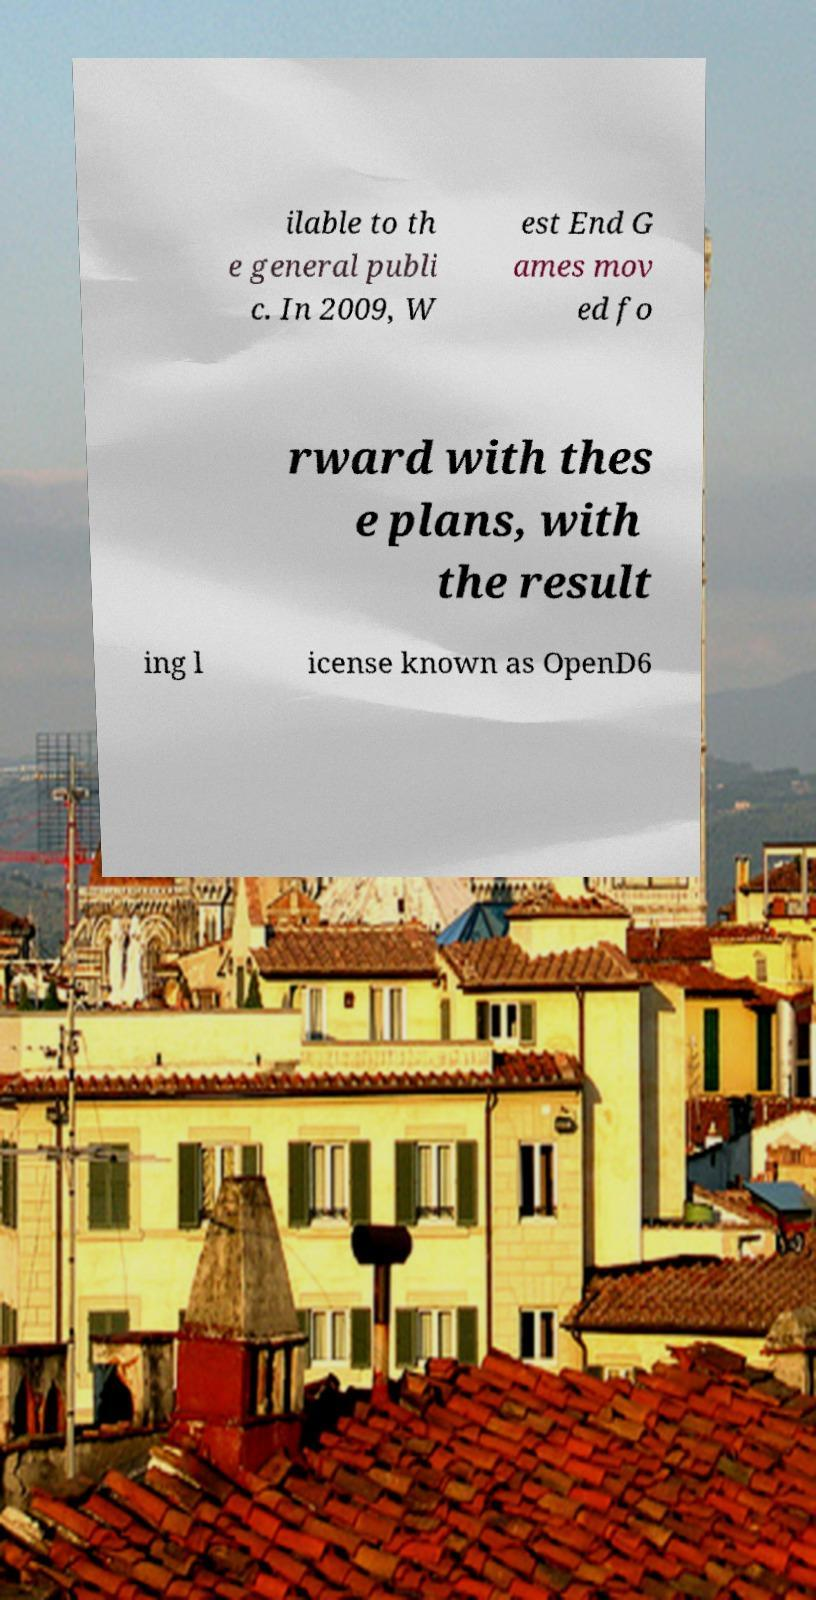Could you assist in decoding the text presented in this image and type it out clearly? ilable to th e general publi c. In 2009, W est End G ames mov ed fo rward with thes e plans, with the result ing l icense known as OpenD6 